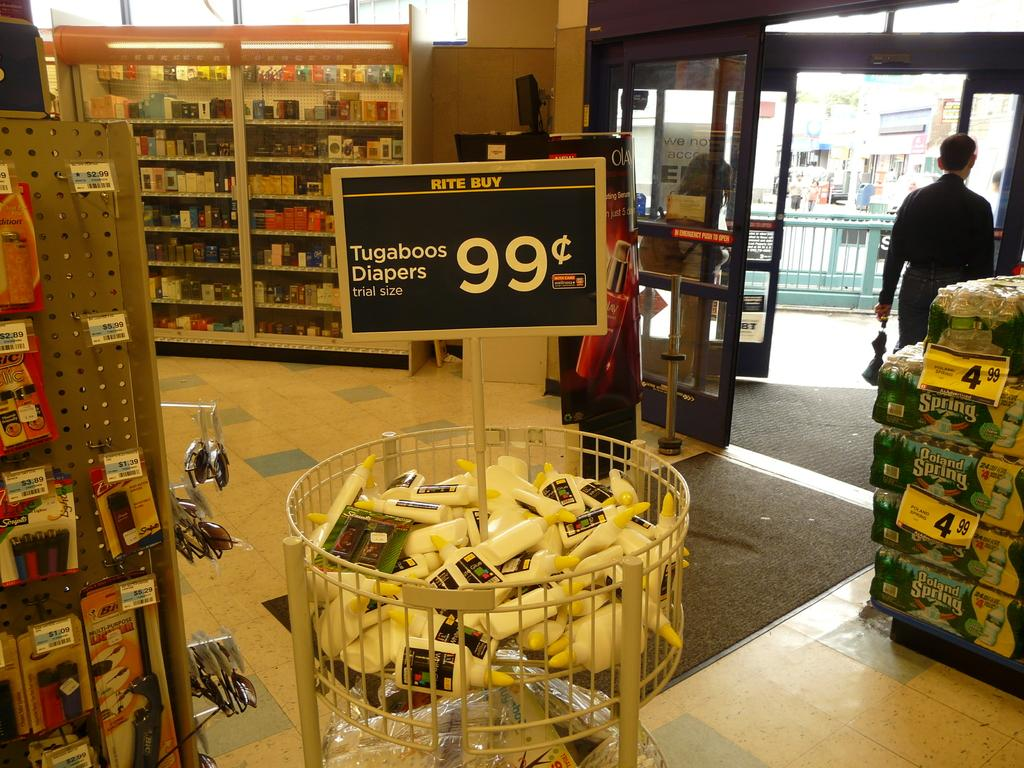<image>
Write a terse but informative summary of the picture. Grocery Store sign in the middle of a bin that has Tugaboos Diapers 99 cents in white lettering. 